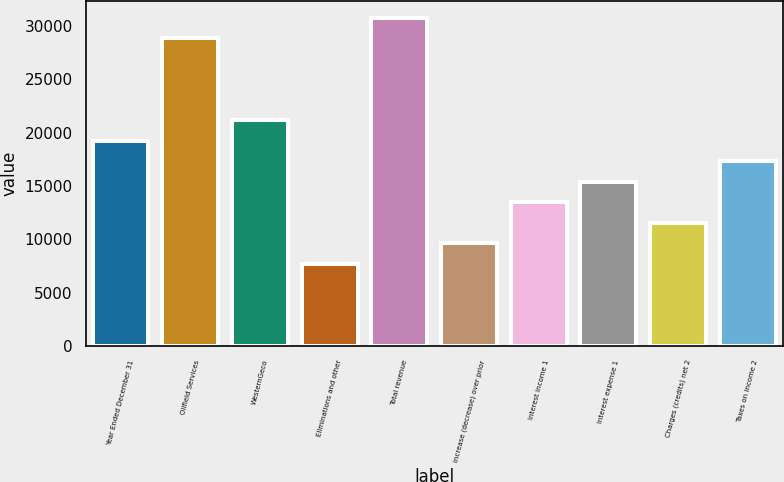Convert chart to OTSL. <chart><loc_0><loc_0><loc_500><loc_500><bar_chart><fcel>Year Ended December 31<fcel>Oilfield Services<fcel>WesternGeco<fcel>Eliminations and other<fcel>Total revenue<fcel>increase (decrease) over prior<fcel>Interest income 1<fcel>Interest expense 1<fcel>Charges (credits) net 2<fcel>Taxes on income 2<nl><fcel>19230<fcel>28844.8<fcel>21153<fcel>7692.3<fcel>30767.7<fcel>9615.25<fcel>13461.1<fcel>15384.1<fcel>11538.2<fcel>17307<nl></chart> 